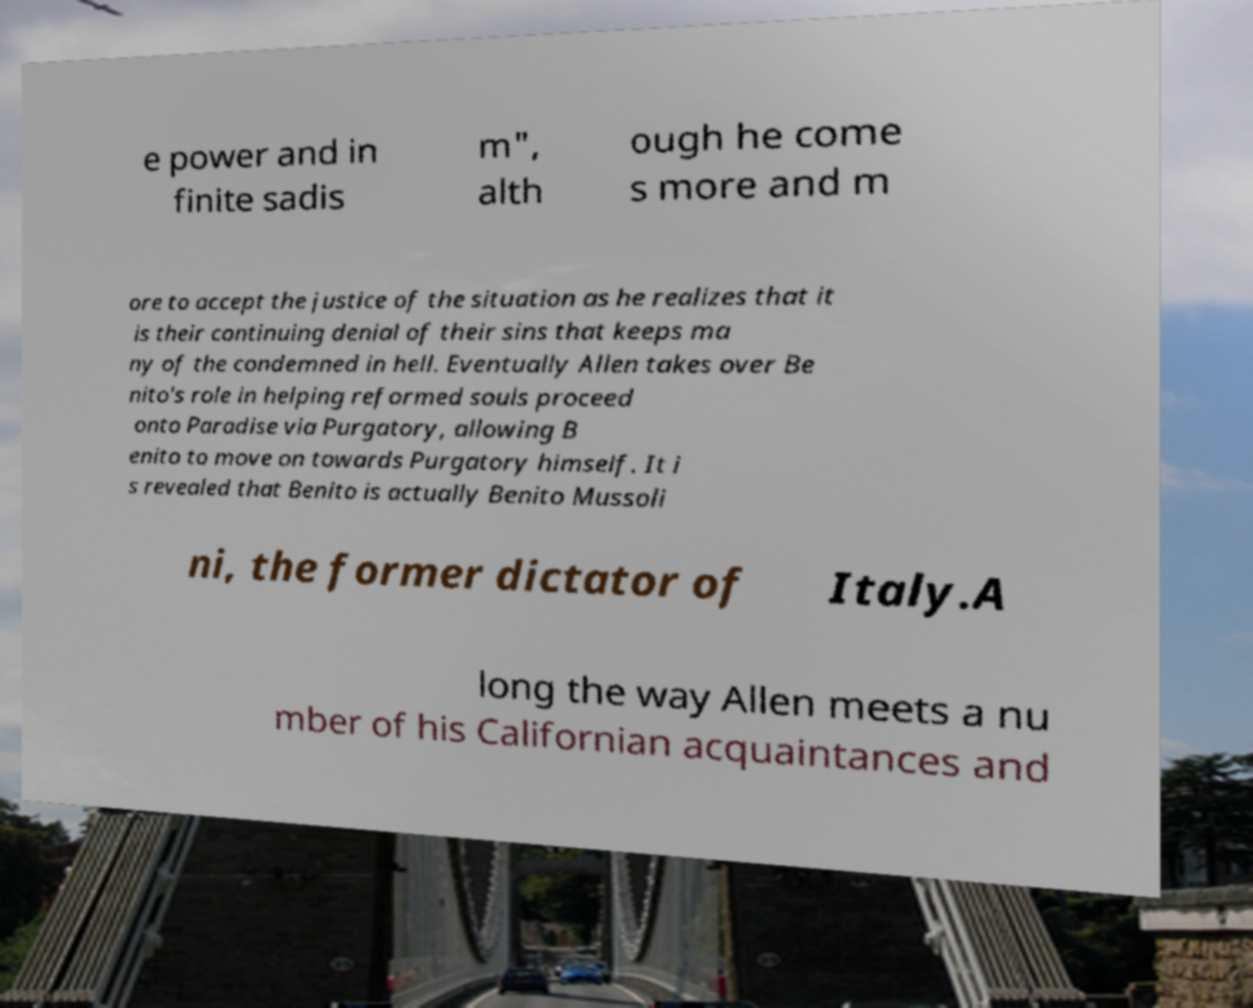Could you extract and type out the text from this image? e power and in finite sadis m", alth ough he come s more and m ore to accept the justice of the situation as he realizes that it is their continuing denial of their sins that keeps ma ny of the condemned in hell. Eventually Allen takes over Be nito's role in helping reformed souls proceed onto Paradise via Purgatory, allowing B enito to move on towards Purgatory himself. It i s revealed that Benito is actually Benito Mussoli ni, the former dictator of Italy.A long the way Allen meets a nu mber of his Californian acquaintances and 